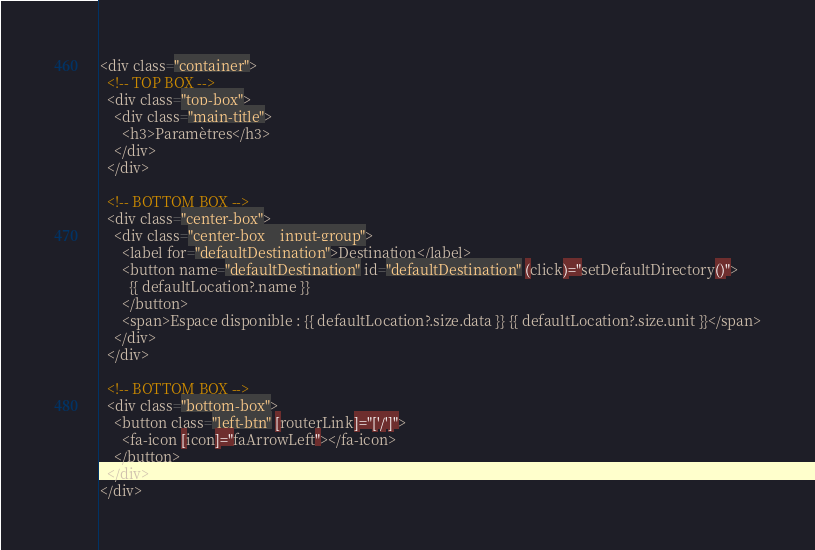<code> <loc_0><loc_0><loc_500><loc_500><_HTML_><div class="container">
  <!-- TOP BOX -->
  <div class="top-box">
    <div class="main-title">
      <h3>Paramètres</h3>
    </div>
  </div>

  <!-- BOTTOM BOX -->
  <div class="center-box">
    <div class="center-box__input-group">
      <label for="defaultDestination">Destination</label>
      <button name="defaultDestination" id="defaultDestination" (click)="setDefaultDirectory()">
        {{ defaultLocation?.name }}
      </button>
      <span>Espace disponible : {{ defaultLocation?.size.data }} {{ defaultLocation?.size.unit }}</span>
    </div>
  </div>

  <!-- BOTTOM BOX -->
  <div class="bottom-box">
    <button class="left-btn" [routerLink]="['/']">
      <fa-icon [icon]="faArrowLeft"></fa-icon>
    </button>
  </div>
</div>
</code> 